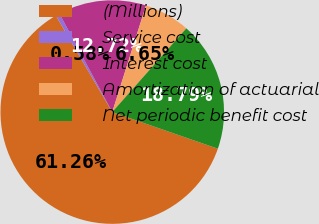Convert chart to OTSL. <chart><loc_0><loc_0><loc_500><loc_500><pie_chart><fcel>(Millions)<fcel>Service cost<fcel>Interest cost<fcel>Amortization of actuarial<fcel>Net periodic benefit cost<nl><fcel>61.27%<fcel>0.58%<fcel>12.72%<fcel>6.65%<fcel>18.79%<nl></chart> 